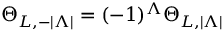<formula> <loc_0><loc_0><loc_500><loc_500>\Theta _ { L , - | \Lambda | } = ( - 1 ) ^ { \Lambda } \Theta _ { L , | \Lambda | }</formula> 